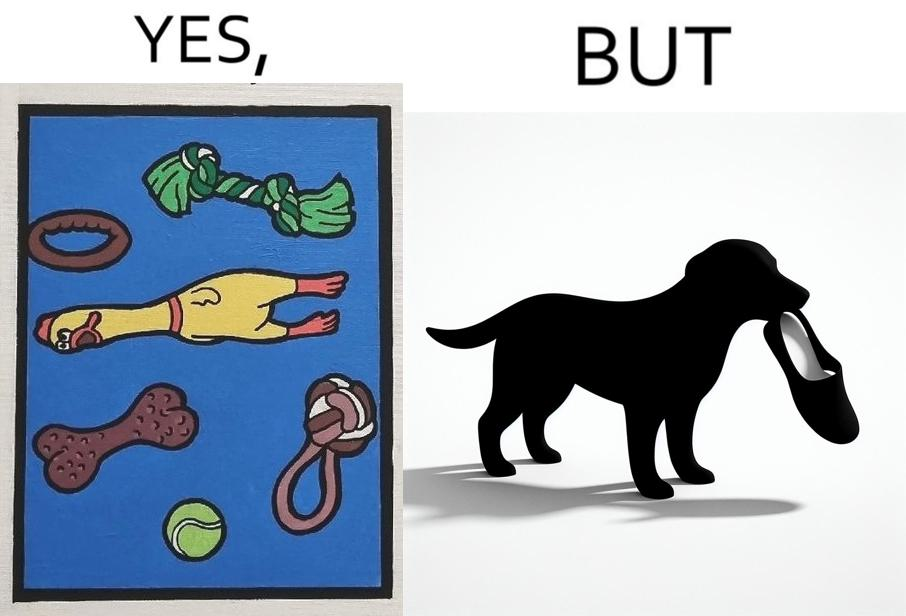Is there satirical content in this image? Yes, this image is satirical. 